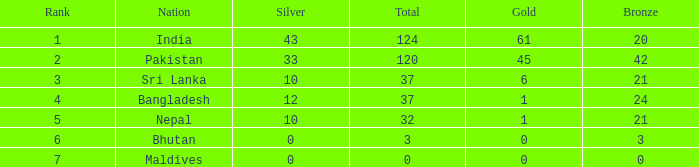Which silver holds a rank of 6, and a bronze fewer than 3? None. 